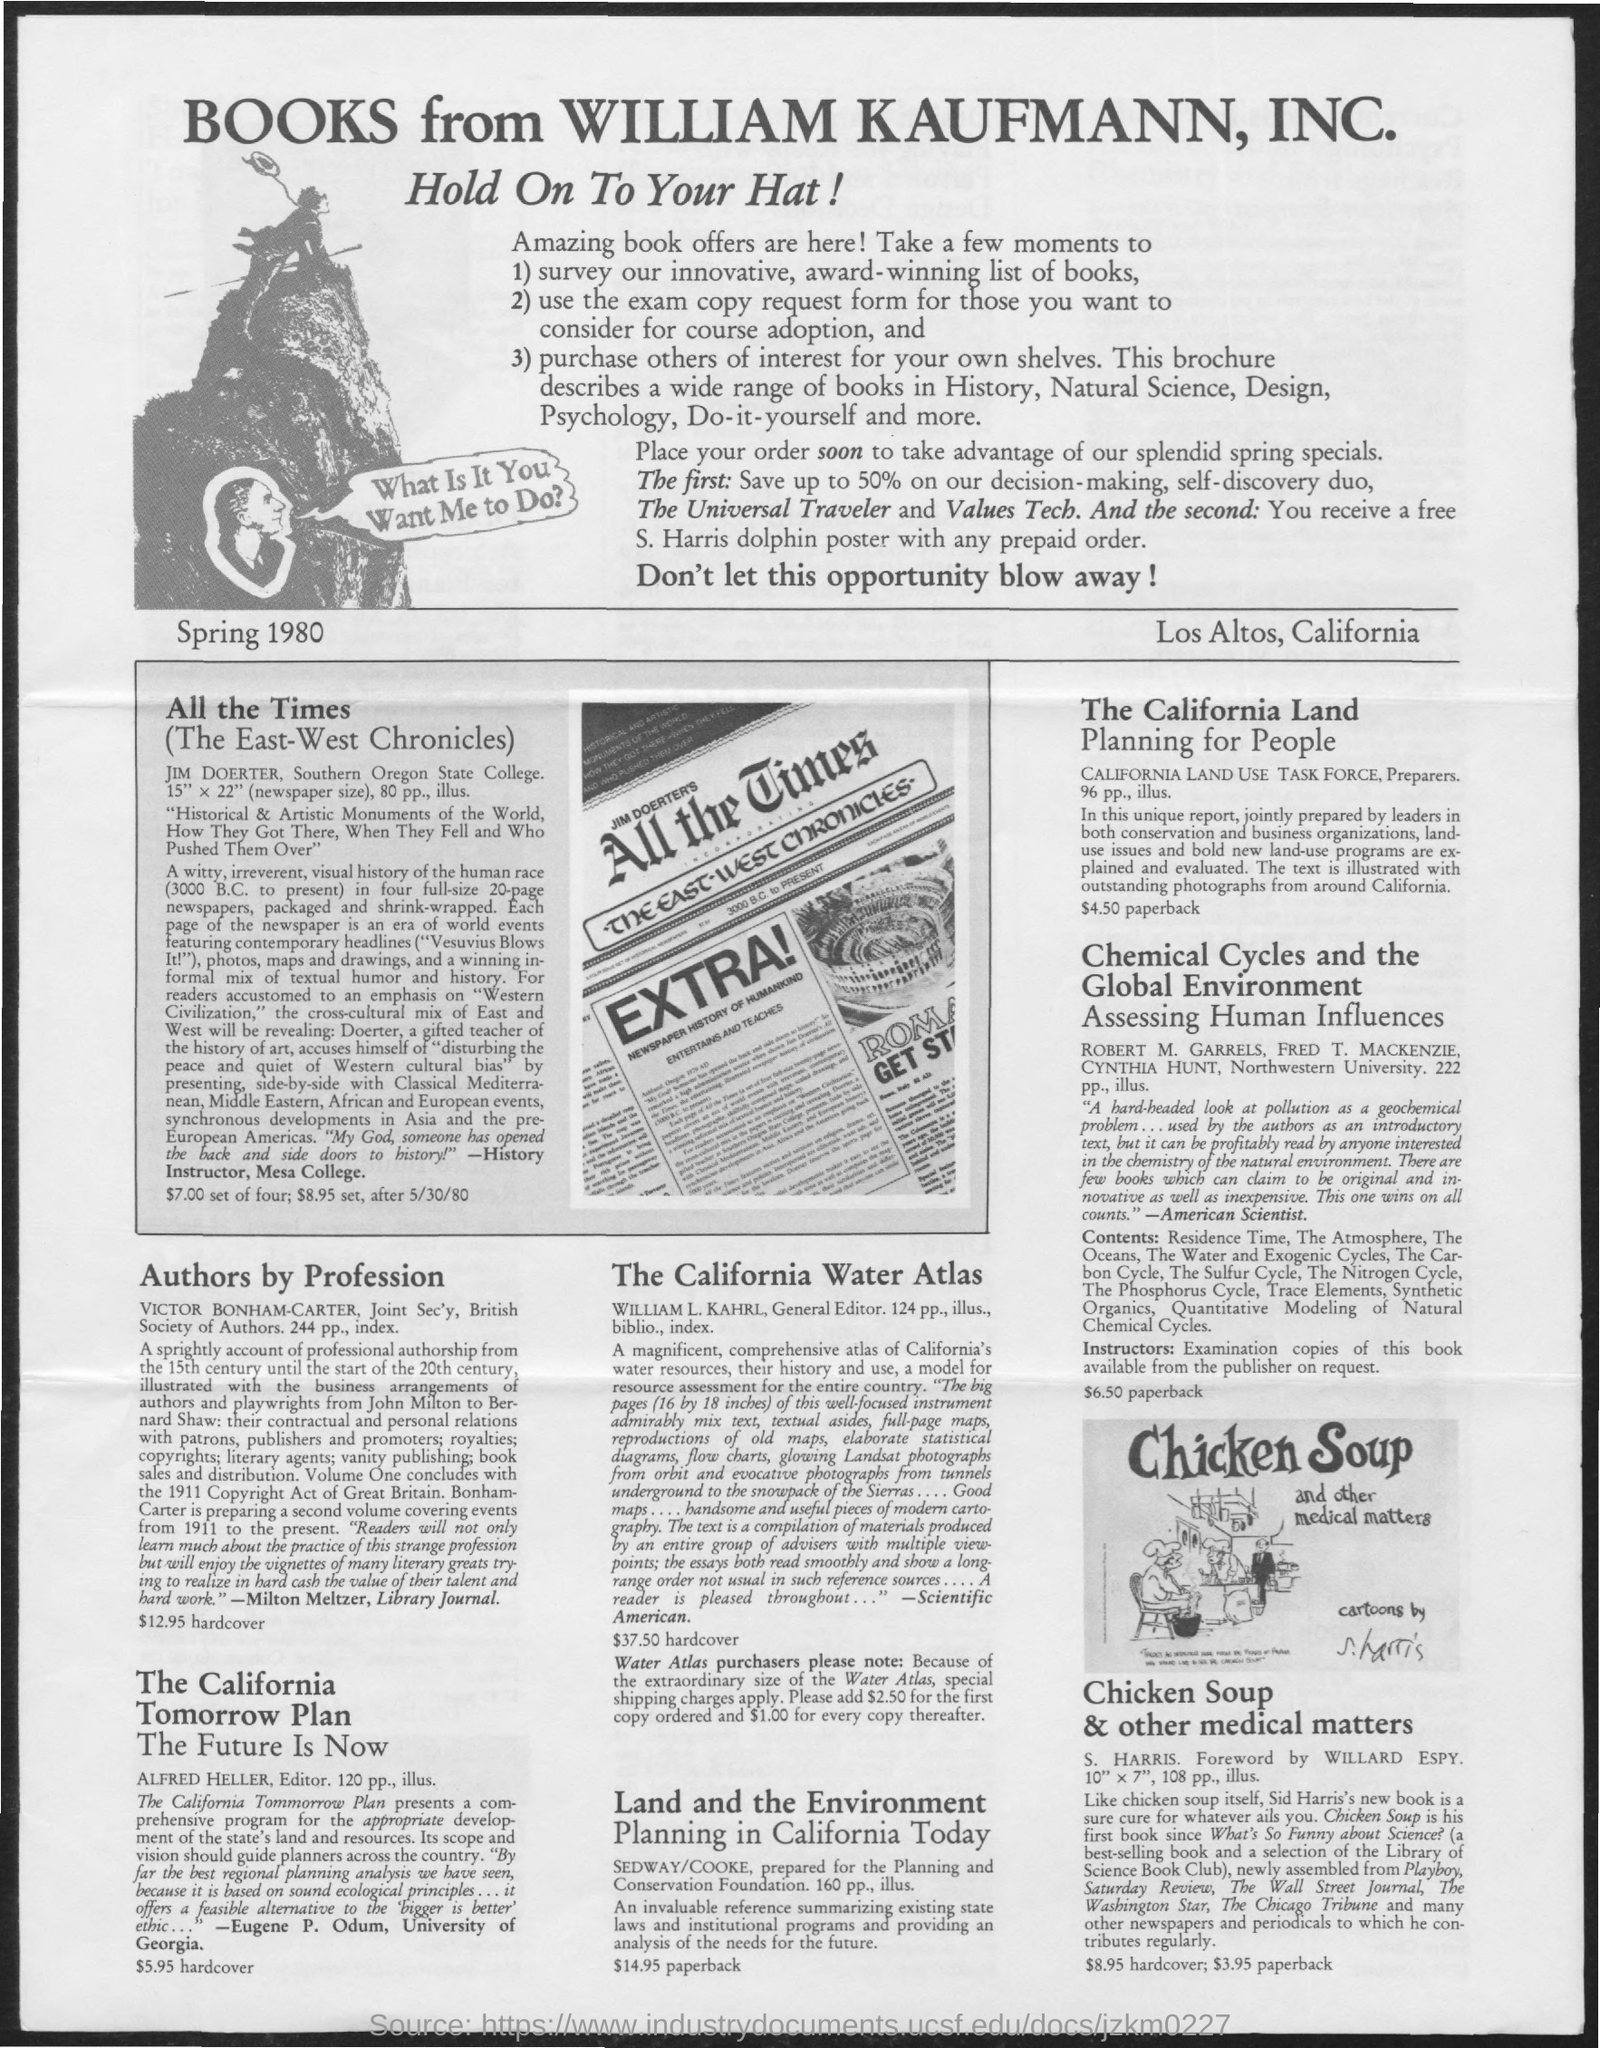Draw attention to some important aspects in this diagram. The document's first title is 'Books from William Kaufmann, Inc.' The second title in the document is 'Hold On To Your Hat!' 